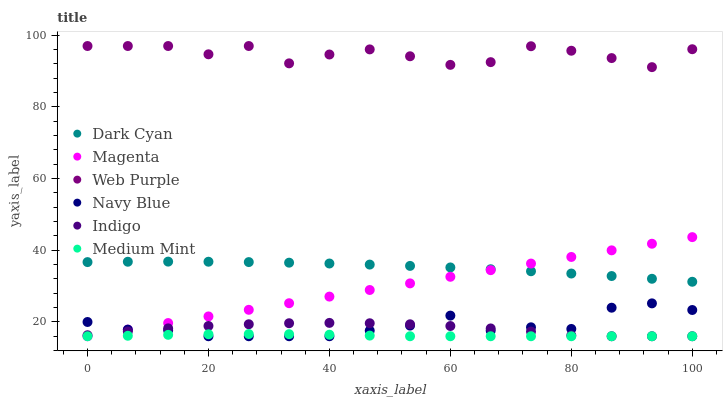Does Medium Mint have the minimum area under the curve?
Answer yes or no. Yes. Does Web Purple have the maximum area under the curve?
Answer yes or no. Yes. Does Indigo have the minimum area under the curve?
Answer yes or no. No. Does Indigo have the maximum area under the curve?
Answer yes or no. No. Is Magenta the smoothest?
Answer yes or no. Yes. Is Web Purple the roughest?
Answer yes or no. Yes. Is Indigo the smoothest?
Answer yes or no. No. Is Indigo the roughest?
Answer yes or no. No. Does Medium Mint have the lowest value?
Answer yes or no. Yes. Does Web Purple have the lowest value?
Answer yes or no. No. Does Web Purple have the highest value?
Answer yes or no. Yes. Does Indigo have the highest value?
Answer yes or no. No. Is Indigo less than Web Purple?
Answer yes or no. Yes. Is Web Purple greater than Indigo?
Answer yes or no. Yes. Does Medium Mint intersect Magenta?
Answer yes or no. Yes. Is Medium Mint less than Magenta?
Answer yes or no. No. Is Medium Mint greater than Magenta?
Answer yes or no. No. Does Indigo intersect Web Purple?
Answer yes or no. No. 